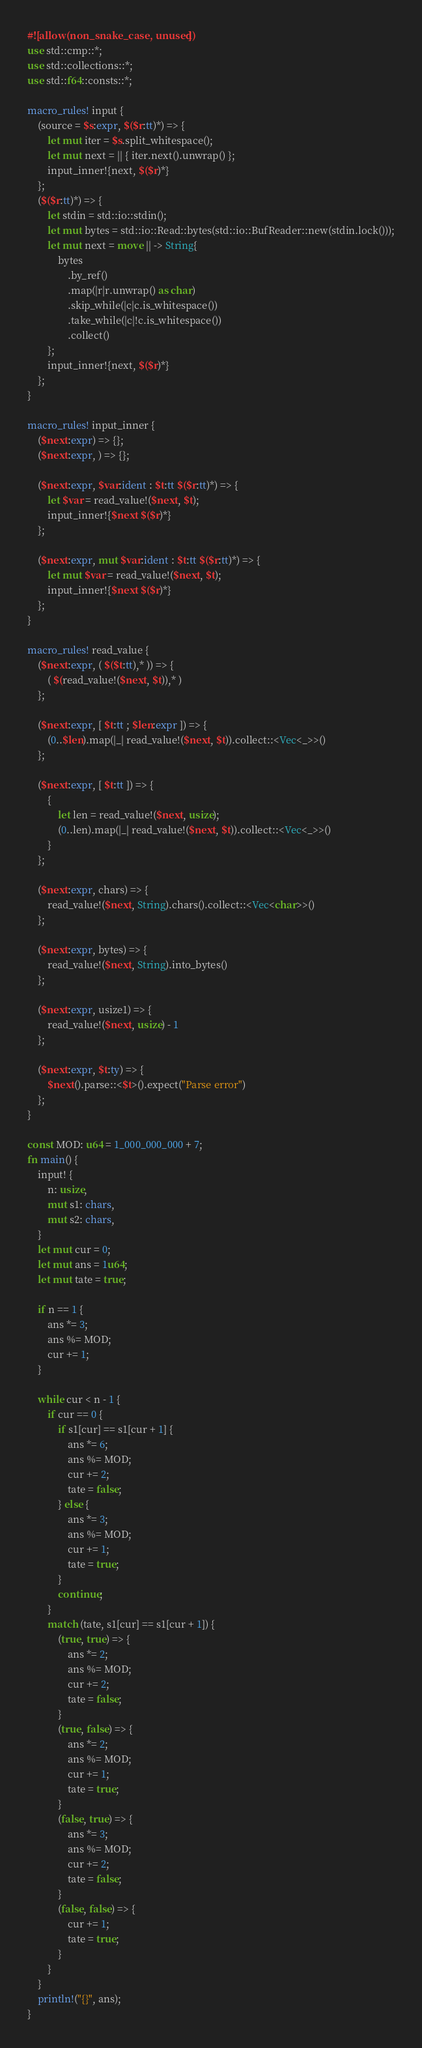<code> <loc_0><loc_0><loc_500><loc_500><_Rust_>#![allow(non_snake_case, unused)]
use std::cmp::*;
use std::collections::*;
use std::f64::consts::*;

macro_rules! input {
    (source = $s:expr, $($r:tt)*) => {
        let mut iter = $s.split_whitespace();
        let mut next = || { iter.next().unwrap() };
        input_inner!{next, $($r)*}
    };
    ($($r:tt)*) => {
        let stdin = std::io::stdin();
        let mut bytes = std::io::Read::bytes(std::io::BufReader::new(stdin.lock()));
        let mut next = move || -> String{
            bytes
                .by_ref()
                .map(|r|r.unwrap() as char)
                .skip_while(|c|c.is_whitespace())
                .take_while(|c|!c.is_whitespace())
                .collect()
        };
        input_inner!{next, $($r)*}
    };
}

macro_rules! input_inner {
    ($next:expr) => {};
    ($next:expr, ) => {};

    ($next:expr, $var:ident : $t:tt $($r:tt)*) => {
        let $var = read_value!($next, $t);
        input_inner!{$next $($r)*}
    };

    ($next:expr, mut $var:ident : $t:tt $($r:tt)*) => {
        let mut $var = read_value!($next, $t);
        input_inner!{$next $($r)*}
    };
}

macro_rules! read_value {
    ($next:expr, ( $($t:tt),* )) => {
        ( $(read_value!($next, $t)),* )
    };

    ($next:expr, [ $t:tt ; $len:expr ]) => {
        (0..$len).map(|_| read_value!($next, $t)).collect::<Vec<_>>()
    };

    ($next:expr, [ $t:tt ]) => {
        {
            let len = read_value!($next, usize);
            (0..len).map(|_| read_value!($next, $t)).collect::<Vec<_>>()
        }
    };

    ($next:expr, chars) => {
        read_value!($next, String).chars().collect::<Vec<char>>()
    };

    ($next:expr, bytes) => {
        read_value!($next, String).into_bytes()
    };

    ($next:expr, usize1) => {
        read_value!($next, usize) - 1
    };

    ($next:expr, $t:ty) => {
        $next().parse::<$t>().expect("Parse error")
    };
}

const MOD: u64 = 1_000_000_000 + 7;
fn main() {
    input! {
        n: usize,
        mut s1: chars,
        mut s2: chars,
    }
    let mut cur = 0;
    let mut ans = 1u64;
    let mut tate = true;

    if n == 1 {
        ans *= 3;
        ans %= MOD;
        cur += 1;
    }

    while cur < n - 1 {
        if cur == 0 {
            if s1[cur] == s1[cur + 1] {
                ans *= 6;
                ans %= MOD;
                cur += 2;
                tate = false;
            } else {
                ans *= 3;
                ans %= MOD;
                cur += 1;
                tate = true;
            }
            continue;
        }
        match (tate, s1[cur] == s1[cur + 1]) {
            (true, true) => {
                ans *= 2;
                ans %= MOD;
                cur += 2;
                tate = false;
            }
            (true, false) => {
                ans *= 2;
                ans %= MOD;
                cur += 1;
                tate = true;
            }
            (false, true) => {
                ans *= 3;
                ans %= MOD;
                cur += 2;
                tate = false;
            }
            (false, false) => {
                cur += 1;
                tate = true;
            }
        }
    }
    println!("{}", ans);
}
</code> 